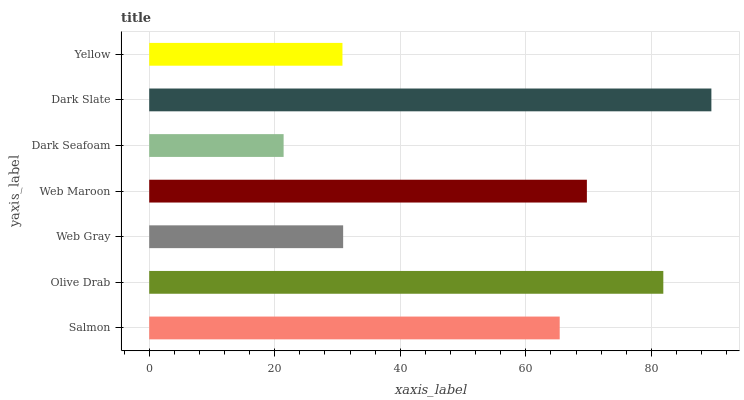Is Dark Seafoam the minimum?
Answer yes or no. Yes. Is Dark Slate the maximum?
Answer yes or no. Yes. Is Olive Drab the minimum?
Answer yes or no. No. Is Olive Drab the maximum?
Answer yes or no. No. Is Olive Drab greater than Salmon?
Answer yes or no. Yes. Is Salmon less than Olive Drab?
Answer yes or no. Yes. Is Salmon greater than Olive Drab?
Answer yes or no. No. Is Olive Drab less than Salmon?
Answer yes or no. No. Is Salmon the high median?
Answer yes or no. Yes. Is Salmon the low median?
Answer yes or no. Yes. Is Dark Slate the high median?
Answer yes or no. No. Is Web Gray the low median?
Answer yes or no. No. 